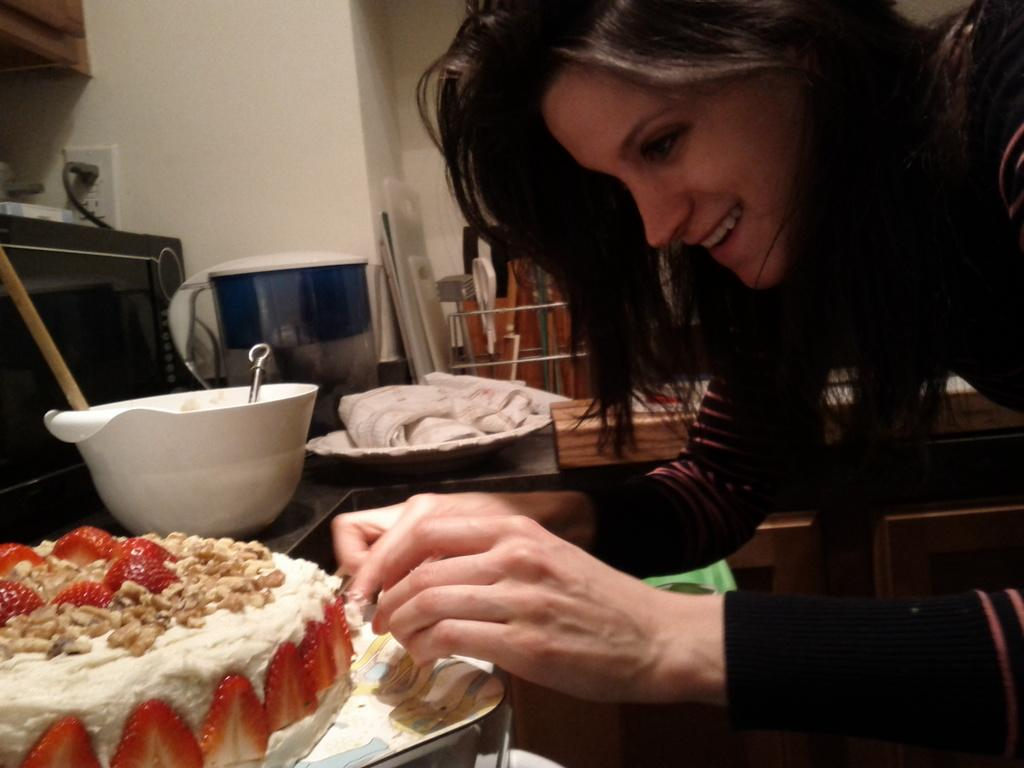Who is the main subject in the image? There is a woman in the image. What is the woman doing in the image? The woman is making a cake. What is the woman's expression in the image? The woman is smiling. Can you describe the bowl in the image? There is a white color bowl on the left side of the image. Where is the power socket located in the image? There is a power socket at the top of the image. How many oranges are being used to make the cake in the image? There is no indication of oranges being used in the image; the woman is making a cake, but the ingredients are not visible. 